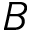Convert formula to latex. <formula><loc_0><loc_0><loc_500><loc_500>B</formula> 